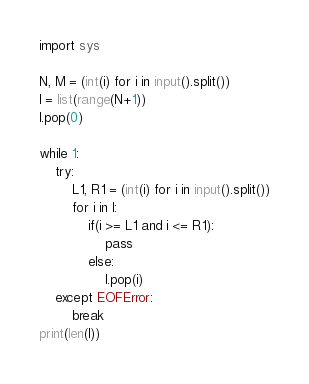<code> <loc_0><loc_0><loc_500><loc_500><_Python_>import sys

N, M = (int(i) for i in input().split())
l = list(range(N+1))
l.pop(0)

while 1:
	try:
		L1, R1 = (int(i) for i in input().split())
		for i in l:
			if(i >= L1 and i <= R1):
				pass
			else:
				l.pop(i)
	except EOFError:
		break
print(len(l))

</code> 